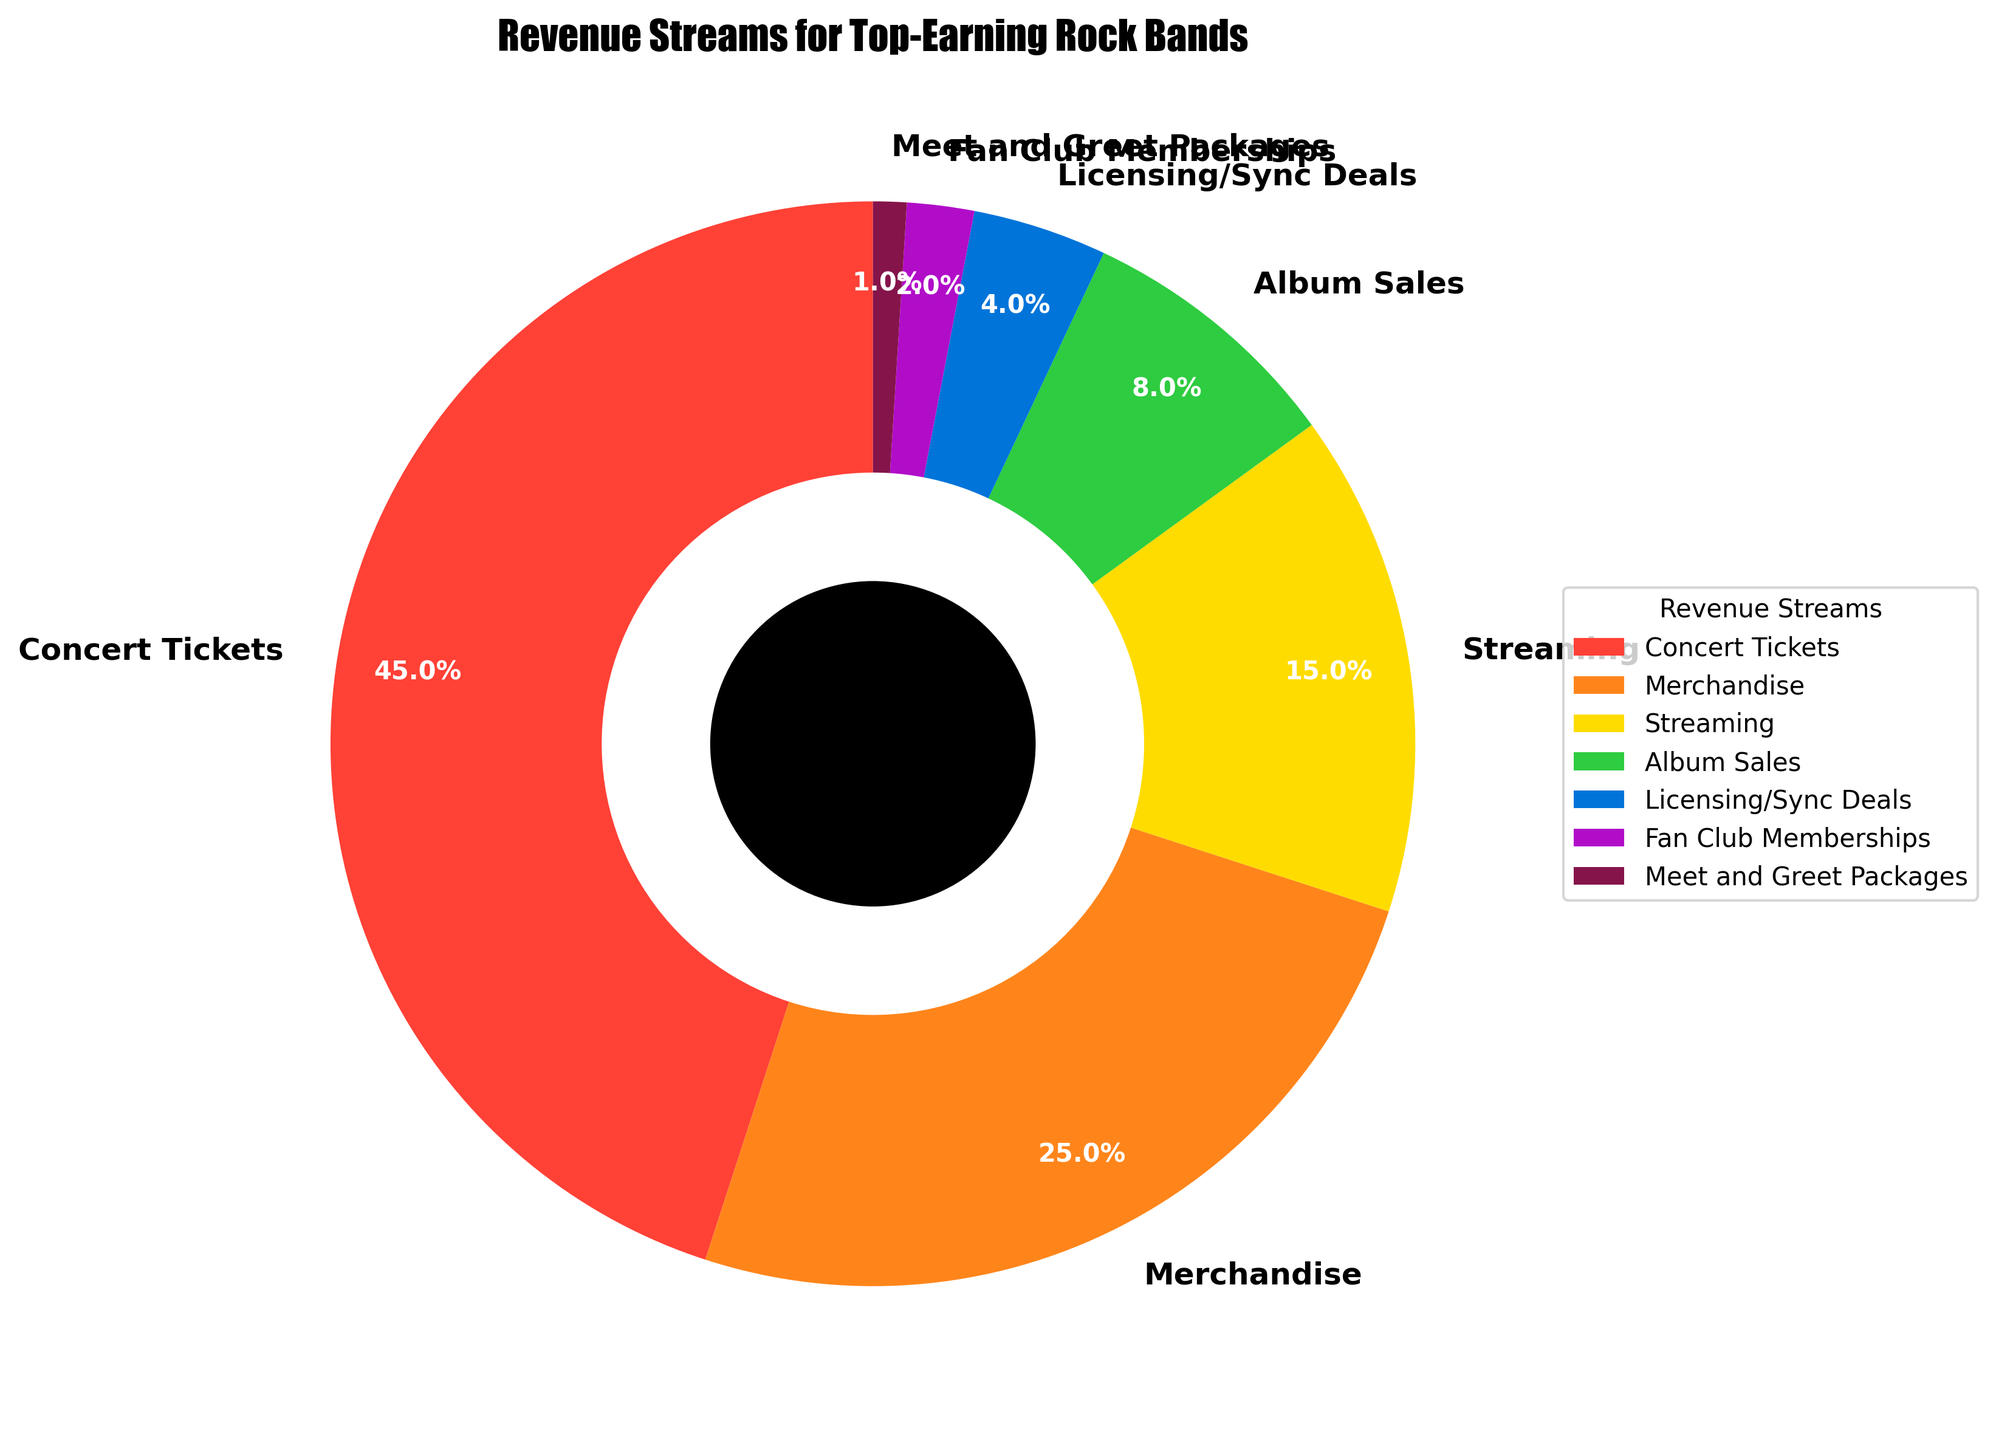Which revenue stream accounts for the largest percentage? The chart indicates that Concert Tickets have the largest segment, visually confirming its dominance.
Answer: Concert Tickets What is the combined percentage for Album Sales and Licensing/Sync Deals? Add the percentages for Album Sales (8%) and Licensing/Sync Deals (4%). 8% + 4% = 12%
Answer: 12% Which two revenue streams together constitute exactly half of the total revenue? Adding up Concert Tickets (45%) and Merchandise (25%) equals 70%, which is over half. Combining Merchandise (25%) and Streaming (15%) yields 40%, which is under half. Adding Concert Tickets (45%) and Merchandise (25%) gets us to 50%. So, these two streams together exactly constitute half the total.
Answer: Concert Tickets and Merchandise Is the fan club membership revenue stream larger than fan meet and greet packages? Visually inspecting the segments, Fan Club Memberships’ percentage (2%) is larger than Meet and Greet Packages (1%), indicating the size difference in the chart.
Answer: Yes What percentage of revenue comes from sources other than Concert Tickets and Merchandise? Subtract the combined percentage of Concert Tickets and Merchandise (45% + 25% = 70%) from 100%. 100% - 70% = 30%
Answer: 30% How does the revenue from Streaming compare to that from Album Sales? The percentage for Streaming (15%) is visibly larger than that for Album Sales (8%), confirming that Streaming generates more revenue.
Answer: Streaming generates more revenue What percentage does the smallest revenue stream represent, and what is it? The smallest slice is Meet and Greet Packages with a 1% share, as reflected visually and numerically.
Answer: 1%, Meet and Greet Packages If we consider Licensing/Sync Deals and Fan Club Memberships together, do they contribute more than Album Sales? Summing Licensing/Sync Deals (4%) and Fan Club Memberships (2%) results in 6%, which is less than Album Sales' 8%. Thus, combined they do not contribute more.
Answer: No What three revenue streams make up 85% of the total revenue? Adding Concert Tickets (45%), Merchandise (25%), and Streaming (15%) reaches a total of 45% + 25% + 15% = 85% of the total revenue, confirmed visually by the large areas of those segments.
Answer: Concert Tickets, Merchandise, and Streaming What is the difference in percentage between Concert Tickets and Streaming? Subtract Streaming’s percentage (15%) from Concert Tickets' percentage (45%). 45% - 15% = 30%
Answer: 30% 